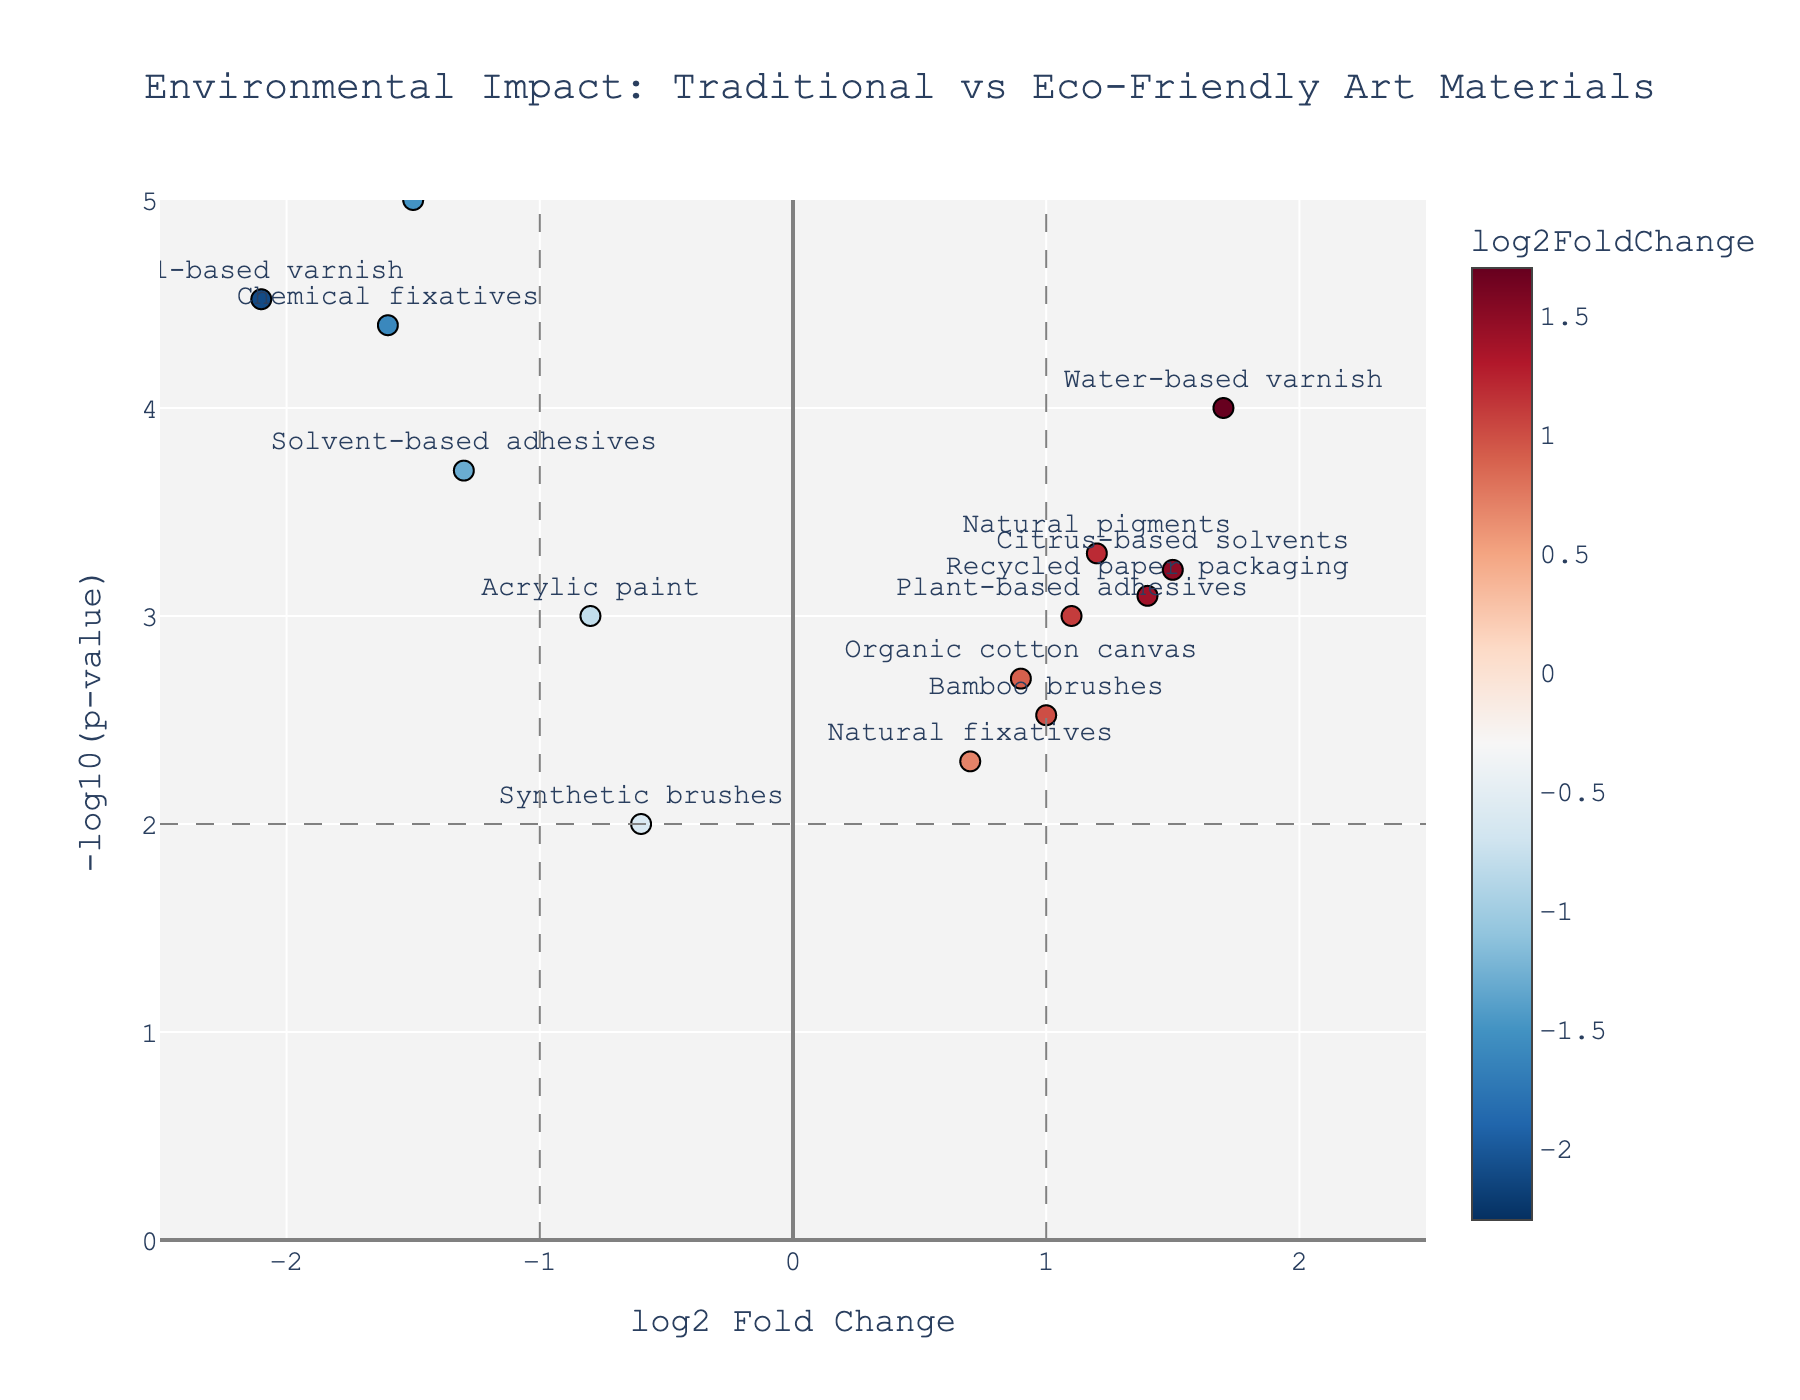What's the title of the plot? The title of the plot can be found at the top center of the figure. It provides a summary of what the plot is about.
Answer: Environmental Impact: Traditional vs Eco-Friendly Art Materials What do the x and y axes represent? The x-axis is labeled "log2 Fold Change," which represents the log2 fold change in environmental impact. The y-axis is labeled "-log10(p-value)," which shows the negative log10 of the p-value.
Answer: x-axis: log2 Fold Change, y-axis: -log10(p-value) How many data points are there in the plot? To find the number of data points, count the markers (points) shown in the plot. Each marker represents one material.
Answer: 16 Which material has the highest negative log2 fold change value? Look at the x-axis for the most negative value and identify the corresponding material.
Answer: Petrochemical solvents Which material has the lowest p-value? The lowest p-value corresponds to the highest y-value in the plot, as the y-axis is -log10(p-value).
Answer: Petrochemical solvents Which materials have a positive log2 fold change and a p-value less than 0.01? Identify points that are to the right of the zero line on the x-axis and above the line that represents a -log10(p-value) of 2 (since -log10(0.01) = 2).
Answer: Natural pigments, Water-based varnish, Recycled paper packaging, Citrus-based solvents How many materials have a log2 fold change greater than 1 and a p-value less than 0.001? Look for points that are to the right of the line at 1 on the x-axis and above the line that represents a -log10(p-value) of 3 (since -log10(0.001) = 3). Count these points.
Answer: 2 (Water-based varnish, Citrus-based solvents) Which materials have a log2 fold change between -1 and 1 and a p-value less than 0.001? Identify points within the range -1 to 1 on the x-axis and above the line that represents a -log10(p-value) of 3.
Answer: None 